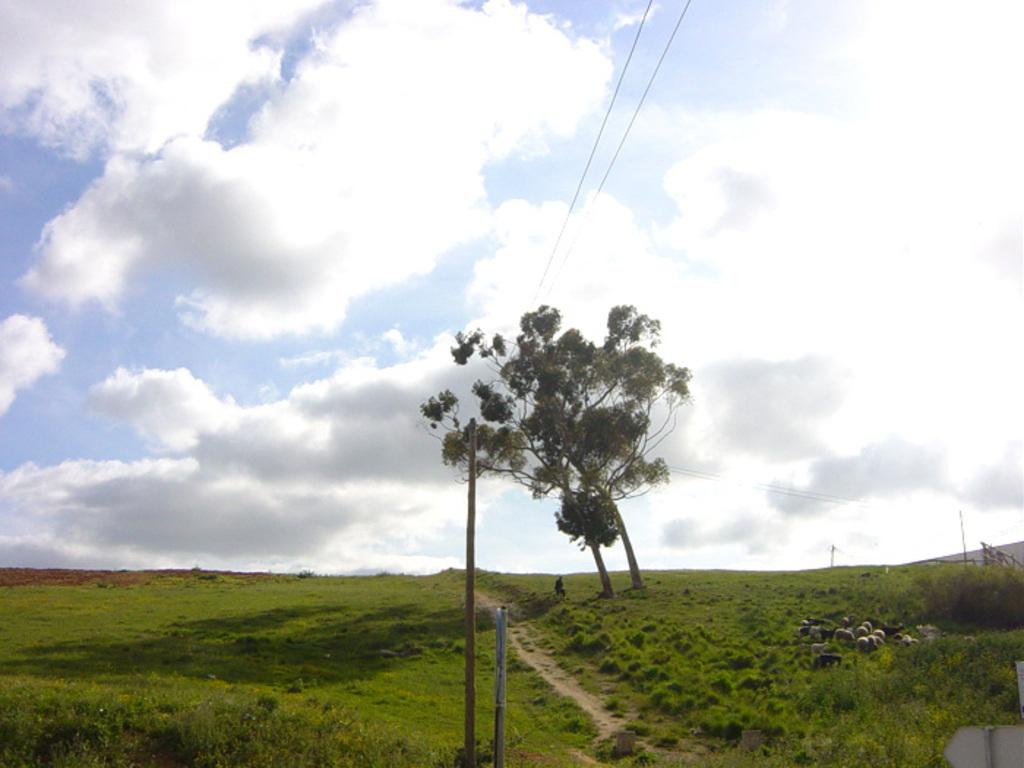What type of landscape is depicted in the image? There is a green field in the image. What animals can be seen in the field? Sheep are grazing in the field. What other natural elements are present in the image? There are trees in the image. Where is the man located in the image? The man is sitting under the trees. What can be seen in the background of the image? The sky is visible in the background of the image. What type of account does the man have with the sheep in the image? There is no indication of any account or relationship between the man and the sheep in the image. 